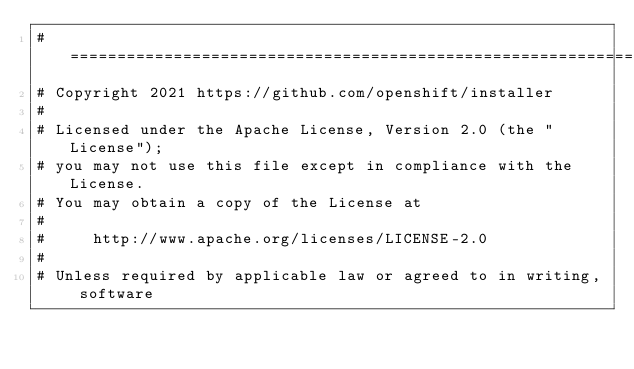Convert code to text. <code><loc_0><loc_0><loc_500><loc_500><_YAML_># =================================================================
# Copyright 2021 https://github.com/openshift/installer
# 
# Licensed under the Apache License, Version 2.0 (the "License");
# you may not use this file except in compliance with the License.
# You may obtain a copy of the License at
# 
#     http://www.apache.org/licenses/LICENSE-2.0
# 
# Unless required by applicable law or agreed to in writing, software</code> 